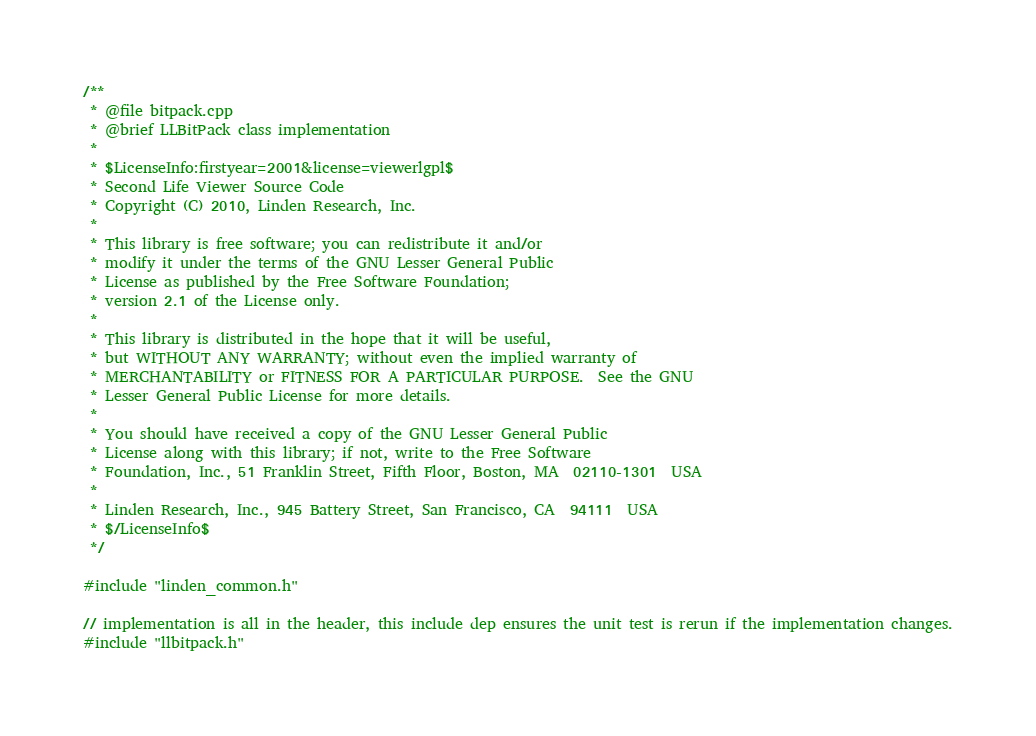Convert code to text. <code><loc_0><loc_0><loc_500><loc_500><_C++_>/** 
 * @file bitpack.cpp
 * @brief LLBitPack class implementation
 *
 * $LicenseInfo:firstyear=2001&license=viewerlgpl$
 * Second Life Viewer Source Code
 * Copyright (C) 2010, Linden Research, Inc.
 * 
 * This library is free software; you can redistribute it and/or
 * modify it under the terms of the GNU Lesser General Public
 * License as published by the Free Software Foundation;
 * version 2.1 of the License only.
 * 
 * This library is distributed in the hope that it will be useful,
 * but WITHOUT ANY WARRANTY; without even the implied warranty of
 * MERCHANTABILITY or FITNESS FOR A PARTICULAR PURPOSE.  See the GNU
 * Lesser General Public License for more details.
 * 
 * You should have received a copy of the GNU Lesser General Public
 * License along with this library; if not, write to the Free Software
 * Foundation, Inc., 51 Franklin Street, Fifth Floor, Boston, MA  02110-1301  USA
 * 
 * Linden Research, Inc., 945 Battery Street, San Francisco, CA  94111  USA
 * $/LicenseInfo$
 */

#include "linden_common.h"

// implementation is all in the header, this include dep ensures the unit test is rerun if the implementation changes.
#include "llbitpack.h"
</code> 